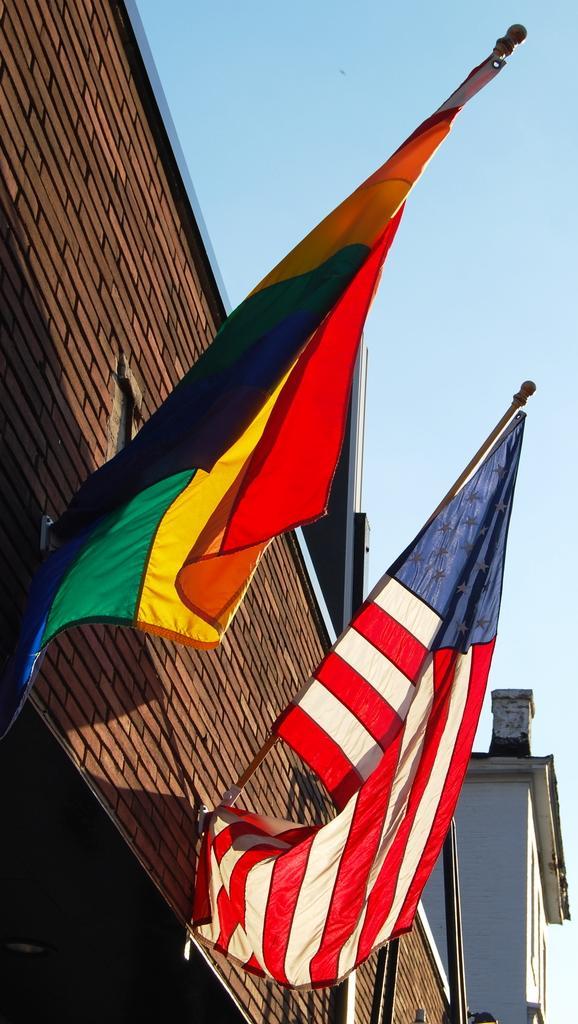Could you give a brief overview of what you see in this image? In this image there is a wall of a building. There are poles to the wall. There are flags to the poles. At the top there is the sky. 